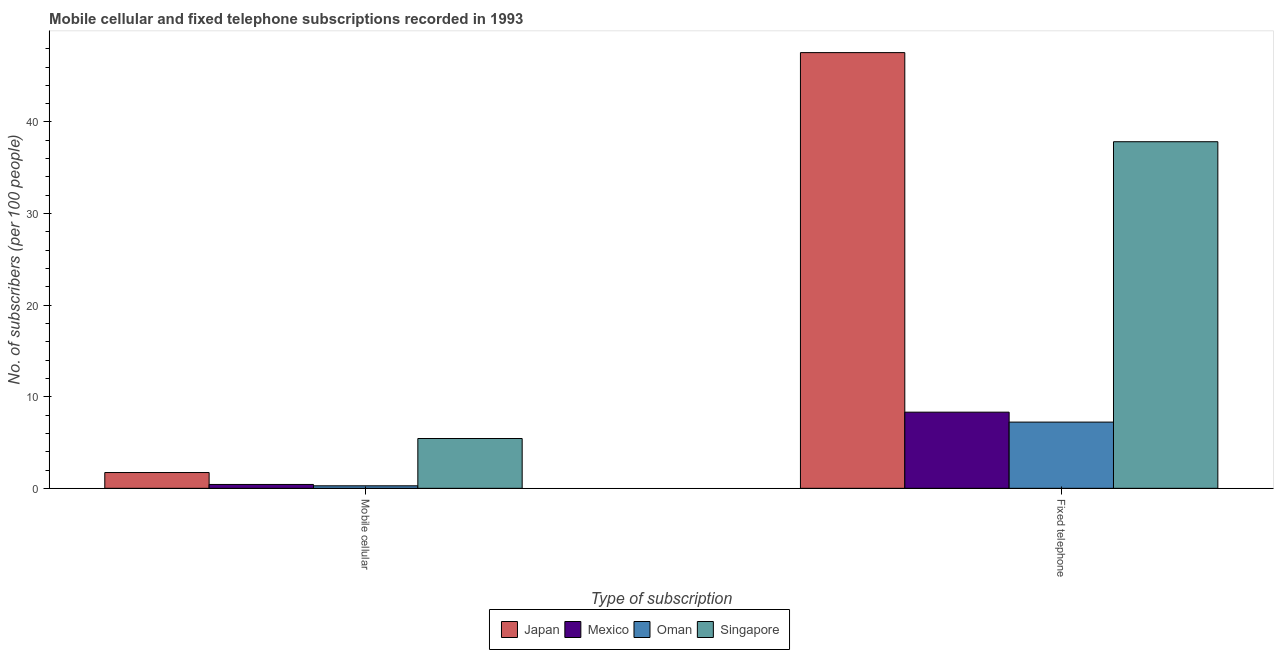How many groups of bars are there?
Offer a terse response. 2. Are the number of bars per tick equal to the number of legend labels?
Provide a succinct answer. Yes. Are the number of bars on each tick of the X-axis equal?
Your answer should be compact. Yes. What is the label of the 2nd group of bars from the left?
Make the answer very short. Fixed telephone. What is the number of mobile cellular subscribers in Japan?
Keep it short and to the point. 1.72. Across all countries, what is the maximum number of fixed telephone subscribers?
Make the answer very short. 47.57. Across all countries, what is the minimum number of mobile cellular subscribers?
Provide a short and direct response. 0.27. In which country was the number of mobile cellular subscribers maximum?
Offer a terse response. Singapore. In which country was the number of mobile cellular subscribers minimum?
Your answer should be compact. Oman. What is the total number of fixed telephone subscribers in the graph?
Make the answer very short. 100.96. What is the difference between the number of fixed telephone subscribers in Japan and that in Mexico?
Provide a short and direct response. 39.26. What is the difference between the number of fixed telephone subscribers in Mexico and the number of mobile cellular subscribers in Singapore?
Provide a short and direct response. 2.88. What is the average number of fixed telephone subscribers per country?
Give a very brief answer. 25.24. What is the difference between the number of mobile cellular subscribers and number of fixed telephone subscribers in Singapore?
Provide a succinct answer. -32.41. What is the ratio of the number of fixed telephone subscribers in Mexico to that in Oman?
Keep it short and to the point. 1.15. Is the number of fixed telephone subscribers in Japan less than that in Singapore?
Your answer should be compact. No. In how many countries, is the number of fixed telephone subscribers greater than the average number of fixed telephone subscribers taken over all countries?
Provide a short and direct response. 2. What does the 2nd bar from the left in Fixed telephone represents?
Provide a succinct answer. Mexico. What does the 3rd bar from the right in Fixed telephone represents?
Ensure brevity in your answer.  Mexico. How many bars are there?
Your answer should be compact. 8. Are all the bars in the graph horizontal?
Offer a very short reply. No. What is the difference between two consecutive major ticks on the Y-axis?
Your response must be concise. 10. Are the values on the major ticks of Y-axis written in scientific E-notation?
Keep it short and to the point. No. Does the graph contain any zero values?
Offer a very short reply. No. Does the graph contain grids?
Offer a very short reply. No. How many legend labels are there?
Offer a terse response. 4. What is the title of the graph?
Your answer should be compact. Mobile cellular and fixed telephone subscriptions recorded in 1993. What is the label or title of the X-axis?
Your answer should be very brief. Type of subscription. What is the label or title of the Y-axis?
Your response must be concise. No. of subscribers (per 100 people). What is the No. of subscribers (per 100 people) in Japan in Mobile cellular?
Offer a very short reply. 1.72. What is the No. of subscribers (per 100 people) in Mexico in Mobile cellular?
Keep it short and to the point. 0.42. What is the No. of subscribers (per 100 people) of Oman in Mobile cellular?
Give a very brief answer. 0.27. What is the No. of subscribers (per 100 people) in Singapore in Mobile cellular?
Make the answer very short. 5.44. What is the No. of subscribers (per 100 people) in Japan in Fixed telephone?
Provide a succinct answer. 47.57. What is the No. of subscribers (per 100 people) of Mexico in Fixed telephone?
Your answer should be very brief. 8.31. What is the No. of subscribers (per 100 people) in Oman in Fixed telephone?
Your response must be concise. 7.23. What is the No. of subscribers (per 100 people) in Singapore in Fixed telephone?
Provide a short and direct response. 37.84. Across all Type of subscription, what is the maximum No. of subscribers (per 100 people) of Japan?
Ensure brevity in your answer.  47.57. Across all Type of subscription, what is the maximum No. of subscribers (per 100 people) in Mexico?
Provide a succinct answer. 8.31. Across all Type of subscription, what is the maximum No. of subscribers (per 100 people) in Oman?
Your answer should be very brief. 7.23. Across all Type of subscription, what is the maximum No. of subscribers (per 100 people) of Singapore?
Provide a succinct answer. 37.84. Across all Type of subscription, what is the minimum No. of subscribers (per 100 people) in Japan?
Provide a succinct answer. 1.72. Across all Type of subscription, what is the minimum No. of subscribers (per 100 people) in Mexico?
Your answer should be compact. 0.42. Across all Type of subscription, what is the minimum No. of subscribers (per 100 people) in Oman?
Provide a succinct answer. 0.27. Across all Type of subscription, what is the minimum No. of subscribers (per 100 people) in Singapore?
Provide a succinct answer. 5.44. What is the total No. of subscribers (per 100 people) of Japan in the graph?
Your response must be concise. 49.3. What is the total No. of subscribers (per 100 people) in Mexico in the graph?
Ensure brevity in your answer.  8.74. What is the total No. of subscribers (per 100 people) of Oman in the graph?
Provide a succinct answer. 7.51. What is the total No. of subscribers (per 100 people) in Singapore in the graph?
Give a very brief answer. 43.28. What is the difference between the No. of subscribers (per 100 people) in Japan in Mobile cellular and that in Fixed telephone?
Ensure brevity in your answer.  -45.85. What is the difference between the No. of subscribers (per 100 people) in Mexico in Mobile cellular and that in Fixed telephone?
Give a very brief answer. -7.89. What is the difference between the No. of subscribers (per 100 people) of Oman in Mobile cellular and that in Fixed telephone?
Your answer should be very brief. -6.96. What is the difference between the No. of subscribers (per 100 people) in Singapore in Mobile cellular and that in Fixed telephone?
Make the answer very short. -32.41. What is the difference between the No. of subscribers (per 100 people) in Japan in Mobile cellular and the No. of subscribers (per 100 people) in Mexico in Fixed telephone?
Your answer should be very brief. -6.59. What is the difference between the No. of subscribers (per 100 people) in Japan in Mobile cellular and the No. of subscribers (per 100 people) in Oman in Fixed telephone?
Make the answer very short. -5.51. What is the difference between the No. of subscribers (per 100 people) of Japan in Mobile cellular and the No. of subscribers (per 100 people) of Singapore in Fixed telephone?
Offer a terse response. -36.12. What is the difference between the No. of subscribers (per 100 people) in Mexico in Mobile cellular and the No. of subscribers (per 100 people) in Oman in Fixed telephone?
Ensure brevity in your answer.  -6.81. What is the difference between the No. of subscribers (per 100 people) in Mexico in Mobile cellular and the No. of subscribers (per 100 people) in Singapore in Fixed telephone?
Provide a succinct answer. -37.42. What is the difference between the No. of subscribers (per 100 people) in Oman in Mobile cellular and the No. of subscribers (per 100 people) in Singapore in Fixed telephone?
Your response must be concise. -37.57. What is the average No. of subscribers (per 100 people) of Japan per Type of subscription?
Your response must be concise. 24.65. What is the average No. of subscribers (per 100 people) in Mexico per Type of subscription?
Provide a succinct answer. 4.37. What is the average No. of subscribers (per 100 people) of Oman per Type of subscription?
Offer a very short reply. 3.75. What is the average No. of subscribers (per 100 people) of Singapore per Type of subscription?
Keep it short and to the point. 21.64. What is the difference between the No. of subscribers (per 100 people) in Japan and No. of subscribers (per 100 people) in Mexico in Mobile cellular?
Keep it short and to the point. 1.3. What is the difference between the No. of subscribers (per 100 people) of Japan and No. of subscribers (per 100 people) of Oman in Mobile cellular?
Make the answer very short. 1.45. What is the difference between the No. of subscribers (per 100 people) of Japan and No. of subscribers (per 100 people) of Singapore in Mobile cellular?
Your response must be concise. -3.71. What is the difference between the No. of subscribers (per 100 people) of Mexico and No. of subscribers (per 100 people) of Oman in Mobile cellular?
Offer a terse response. 0.15. What is the difference between the No. of subscribers (per 100 people) in Mexico and No. of subscribers (per 100 people) in Singapore in Mobile cellular?
Provide a succinct answer. -5.02. What is the difference between the No. of subscribers (per 100 people) of Oman and No. of subscribers (per 100 people) of Singapore in Mobile cellular?
Ensure brevity in your answer.  -5.16. What is the difference between the No. of subscribers (per 100 people) of Japan and No. of subscribers (per 100 people) of Mexico in Fixed telephone?
Give a very brief answer. 39.26. What is the difference between the No. of subscribers (per 100 people) of Japan and No. of subscribers (per 100 people) of Oman in Fixed telephone?
Your answer should be compact. 40.34. What is the difference between the No. of subscribers (per 100 people) in Japan and No. of subscribers (per 100 people) in Singapore in Fixed telephone?
Offer a very short reply. 9.73. What is the difference between the No. of subscribers (per 100 people) of Mexico and No. of subscribers (per 100 people) of Oman in Fixed telephone?
Make the answer very short. 1.08. What is the difference between the No. of subscribers (per 100 people) of Mexico and No. of subscribers (per 100 people) of Singapore in Fixed telephone?
Keep it short and to the point. -29.53. What is the difference between the No. of subscribers (per 100 people) in Oman and No. of subscribers (per 100 people) in Singapore in Fixed telephone?
Offer a terse response. -30.61. What is the ratio of the No. of subscribers (per 100 people) of Japan in Mobile cellular to that in Fixed telephone?
Make the answer very short. 0.04. What is the ratio of the No. of subscribers (per 100 people) of Mexico in Mobile cellular to that in Fixed telephone?
Your answer should be very brief. 0.05. What is the ratio of the No. of subscribers (per 100 people) of Oman in Mobile cellular to that in Fixed telephone?
Make the answer very short. 0.04. What is the ratio of the No. of subscribers (per 100 people) in Singapore in Mobile cellular to that in Fixed telephone?
Offer a very short reply. 0.14. What is the difference between the highest and the second highest No. of subscribers (per 100 people) of Japan?
Your response must be concise. 45.85. What is the difference between the highest and the second highest No. of subscribers (per 100 people) of Mexico?
Make the answer very short. 7.89. What is the difference between the highest and the second highest No. of subscribers (per 100 people) in Oman?
Your answer should be compact. 6.96. What is the difference between the highest and the second highest No. of subscribers (per 100 people) of Singapore?
Offer a very short reply. 32.41. What is the difference between the highest and the lowest No. of subscribers (per 100 people) in Japan?
Make the answer very short. 45.85. What is the difference between the highest and the lowest No. of subscribers (per 100 people) in Mexico?
Ensure brevity in your answer.  7.89. What is the difference between the highest and the lowest No. of subscribers (per 100 people) of Oman?
Provide a succinct answer. 6.96. What is the difference between the highest and the lowest No. of subscribers (per 100 people) in Singapore?
Your answer should be compact. 32.41. 